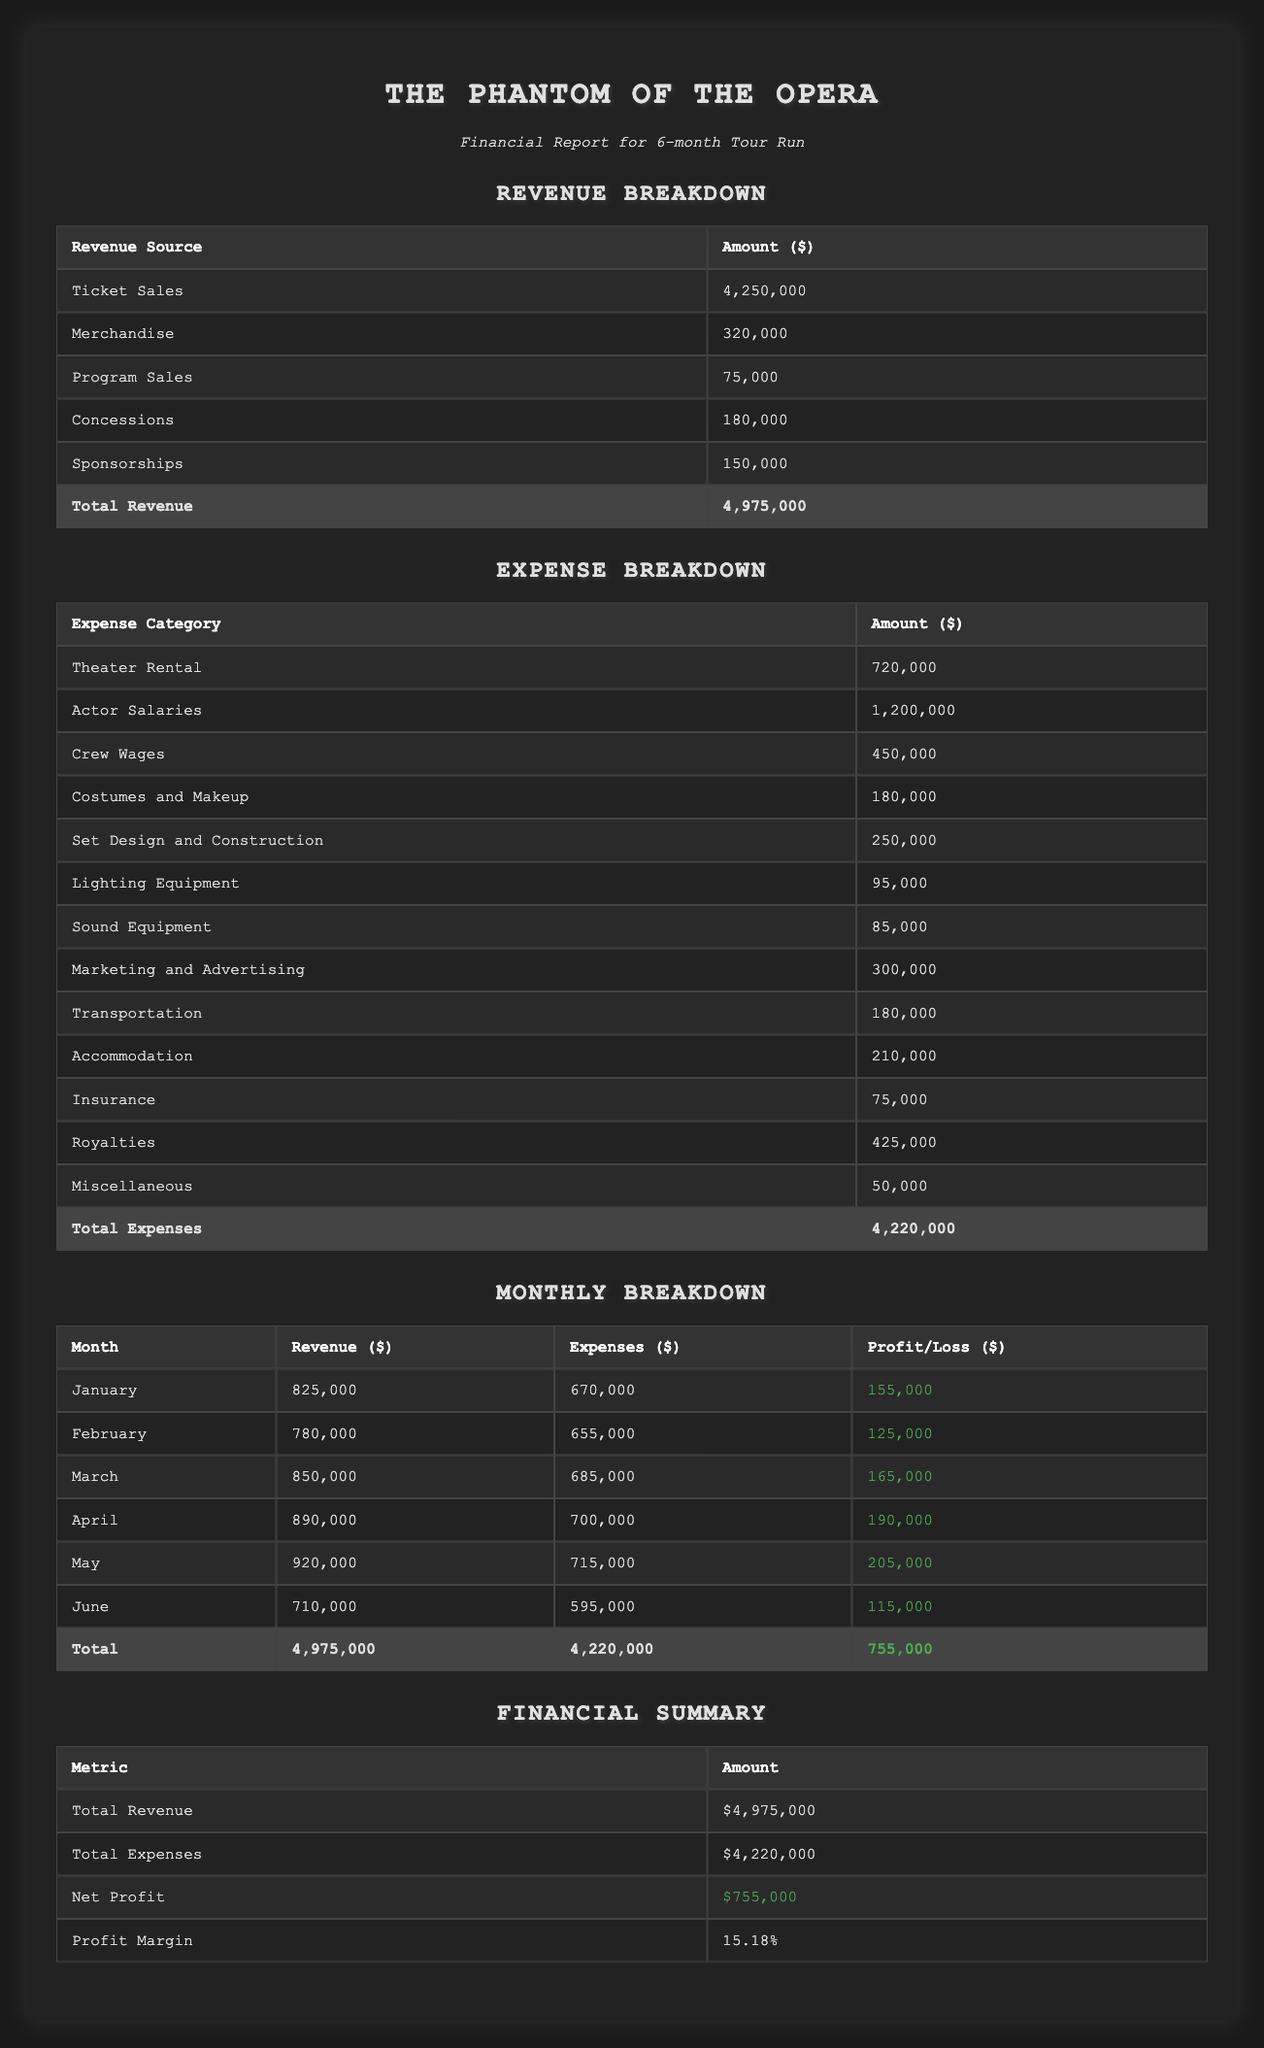What was the total revenue from ticket sales? The table states that the total amount from ticket sales is listed directly as $4,250,000.
Answer: 4,250,000 What was the highest monthly profit during the run? To determine the highest profit month, I compare the profit/loss column for each month. The month with the highest profit is May with $205,000.
Answer: 205,000 Did the production spend more on actor salaries than theater rental? According to the table, actor salaries are $1,200,000 and theater rental is $720,000. Since $1,200,000 is greater than $720,000, the statement is true.
Answer: Yes What was the net profit for the production? The financial summary table explicitly shows the net profit as $755,000.
Answer: 755,000 Calculate the total expenses for the month of March. The table indicates that the expenses for March are $685,000. There are no additional expenses to sum for this month, so the total is directly taken from the table.
Answer: 685,000 Which month had the lowest revenue? The revenues for each month are: January $825,000, February $780,000, March $850,000, April $890,000, May $920,000, June $710,000. The lowest revenue is found in June with $710,000.
Answer: 710,000 How much more were the total expenses than the total revenue? The total expenses are $4,220,000 and total revenue is $4,975,000. To find the difference, I subtract total revenue from total expenses: $4,220,000 - $4,975,000 = -$755,000. This means expenses were less than revenue, thus the correct answer is $755,000 less.
Answer: 755,000 less What percentage of total revenue was generated from merchandise sales? Merchandise sales amount to $320,000. To compute the percentage, use the formula: (merchandise sales / total revenue) * 100. This gives us ($320,000 / $4,975,000) * 100 = 6.43%.
Answer: 6.43% Was the profit margin over 15% for this production? The profit margin is stated as 15.18% in the financial summary table, which confirms that it is indeed over 15%.
Answer: Yes 